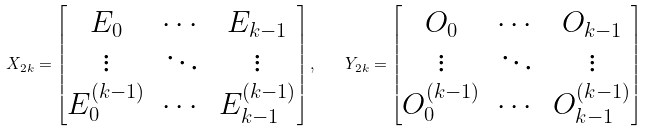<formula> <loc_0><loc_0><loc_500><loc_500>X _ { 2 k } = \begin{bmatrix} E _ { 0 } & \cdots & E _ { k - 1 } \\ \vdots & \ddots & \vdots \\ E ^ { ( k - 1 ) } _ { 0 } & \cdots & E ^ { ( k - 1 ) } _ { k - 1 } \end{bmatrix} , \quad Y _ { 2 k } = \begin{bmatrix} O _ { 0 } & \cdots & O _ { k - 1 } \\ \vdots & \ddots & \vdots \\ O ^ { ( k - 1 ) } _ { 0 } & \cdots & O ^ { ( k - 1 ) } _ { k - 1 } \end{bmatrix}</formula> 